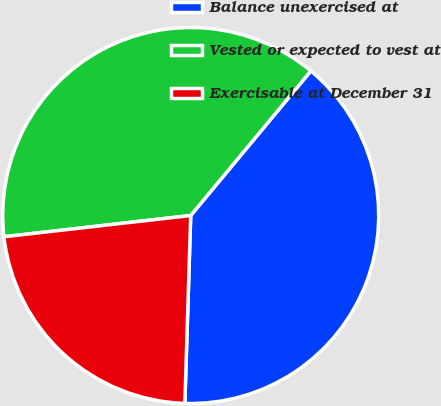Convert chart. <chart><loc_0><loc_0><loc_500><loc_500><pie_chart><fcel>Balance unexercised at<fcel>Vested or expected to vest at<fcel>Exercisable at December 31<nl><fcel>39.46%<fcel>37.84%<fcel>22.7%<nl></chart> 